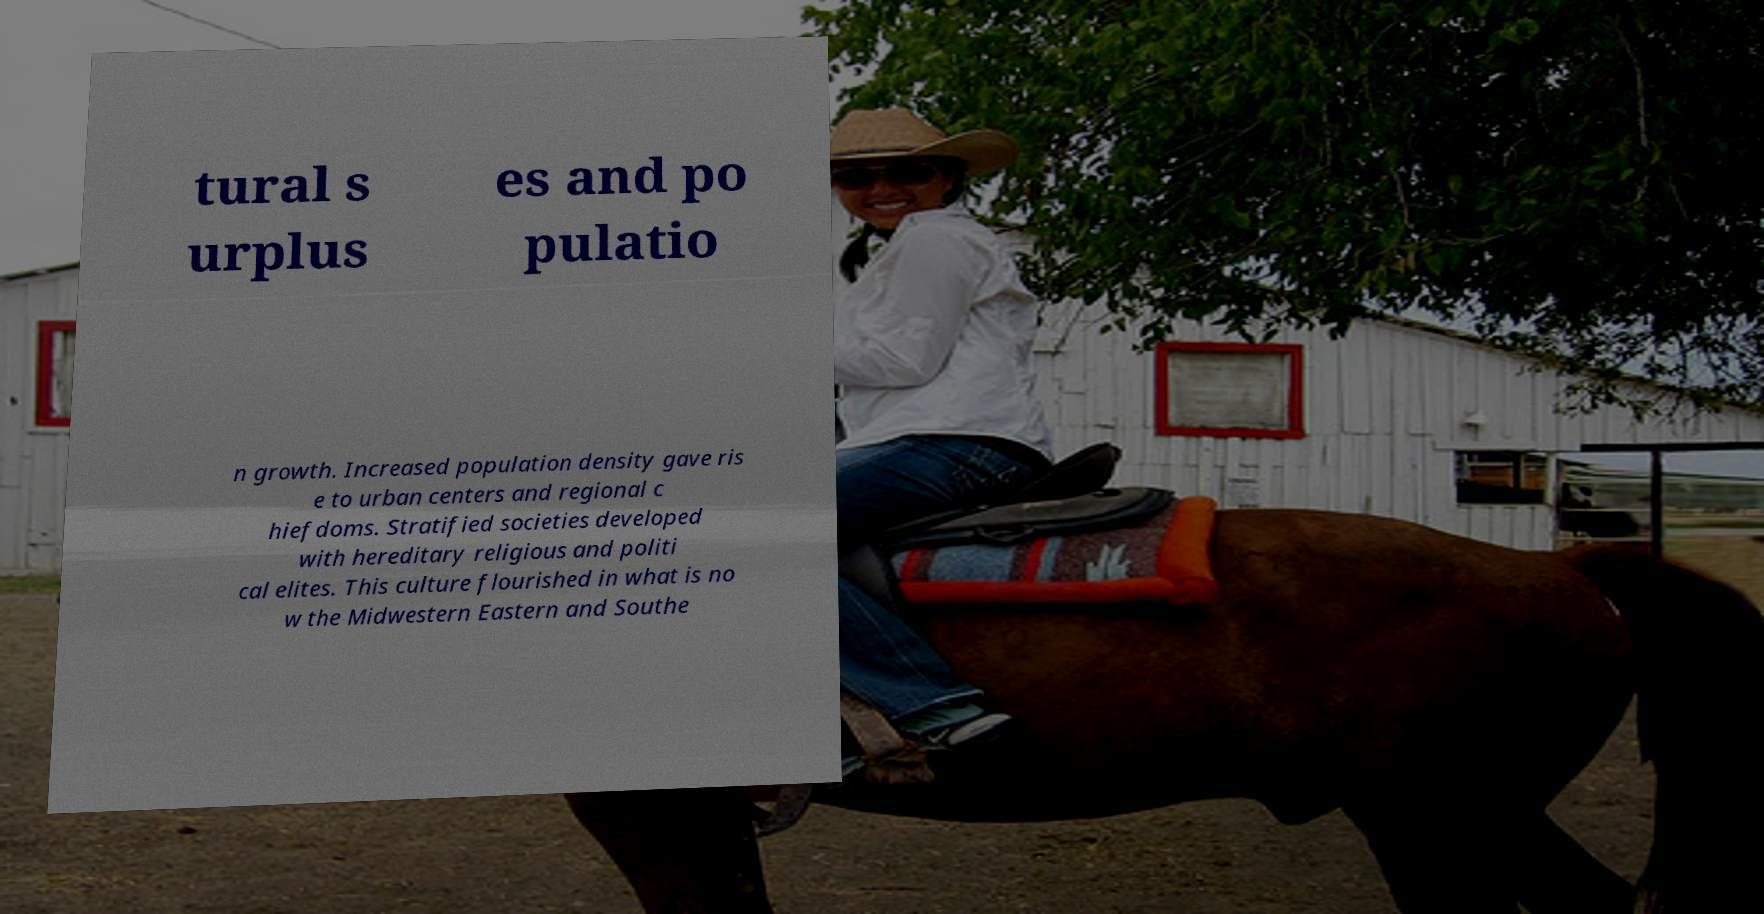Could you extract and type out the text from this image? tural s urplus es and po pulatio n growth. Increased population density gave ris e to urban centers and regional c hiefdoms. Stratified societies developed with hereditary religious and politi cal elites. This culture flourished in what is no w the Midwestern Eastern and Southe 